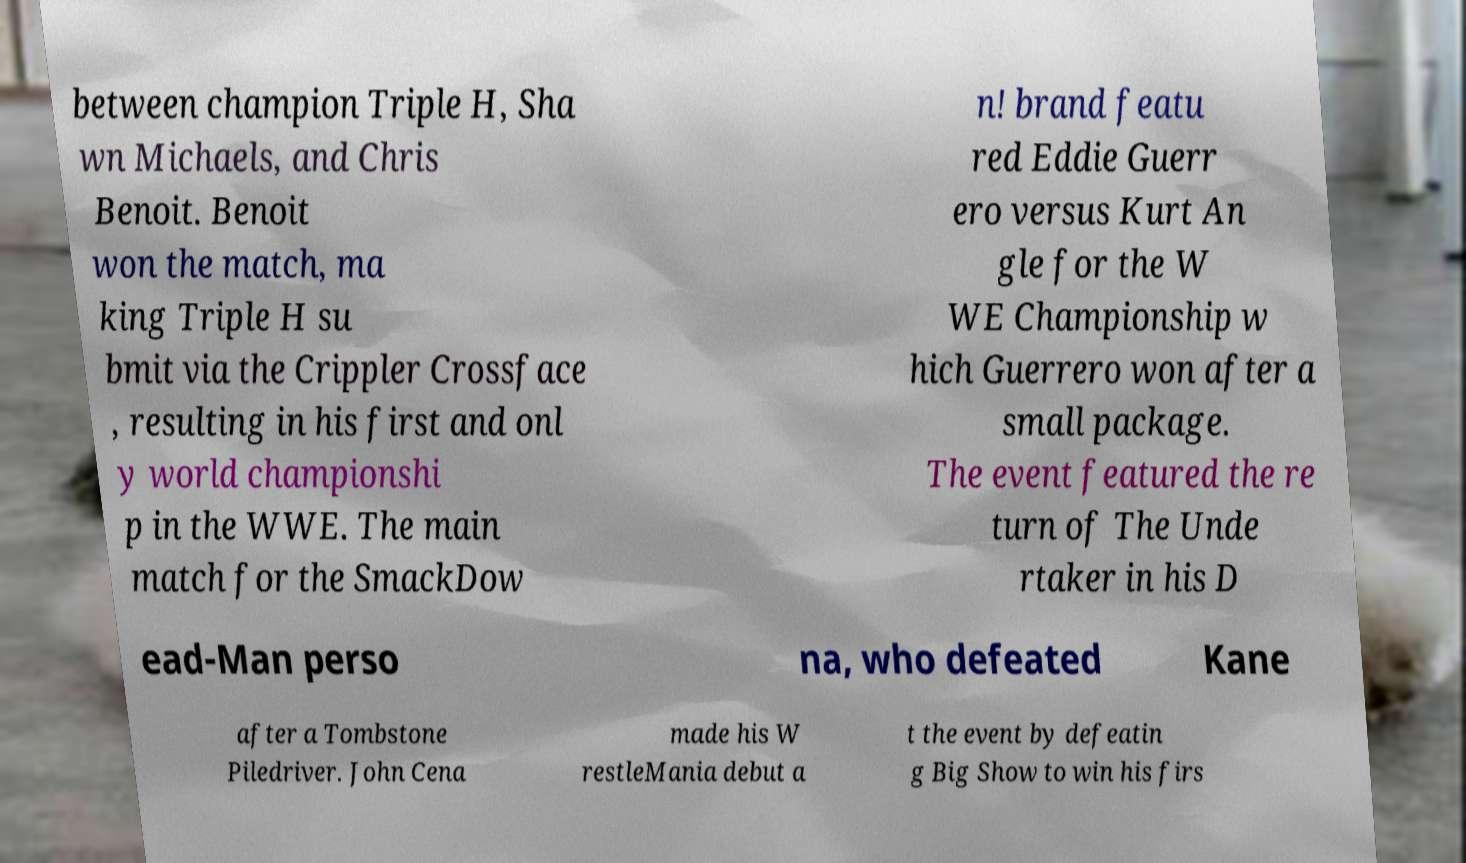What messages or text are displayed in this image? I need them in a readable, typed format. between champion Triple H, Sha wn Michaels, and Chris Benoit. Benoit won the match, ma king Triple H su bmit via the Crippler Crossface , resulting in his first and onl y world championshi p in the WWE. The main match for the SmackDow n! brand featu red Eddie Guerr ero versus Kurt An gle for the W WE Championship w hich Guerrero won after a small package. The event featured the re turn of The Unde rtaker in his D ead-Man perso na, who defeated Kane after a Tombstone Piledriver. John Cena made his W restleMania debut a t the event by defeatin g Big Show to win his firs 